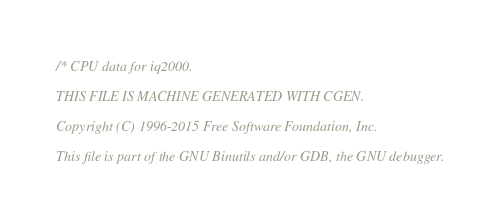<code> <loc_0><loc_0><loc_500><loc_500><_C_>/* CPU data for iq2000.

THIS FILE IS MACHINE GENERATED WITH CGEN.

Copyright (C) 1996-2015 Free Software Foundation, Inc.

This file is part of the GNU Binutils and/or GDB, the GNU debugger.
</code> 